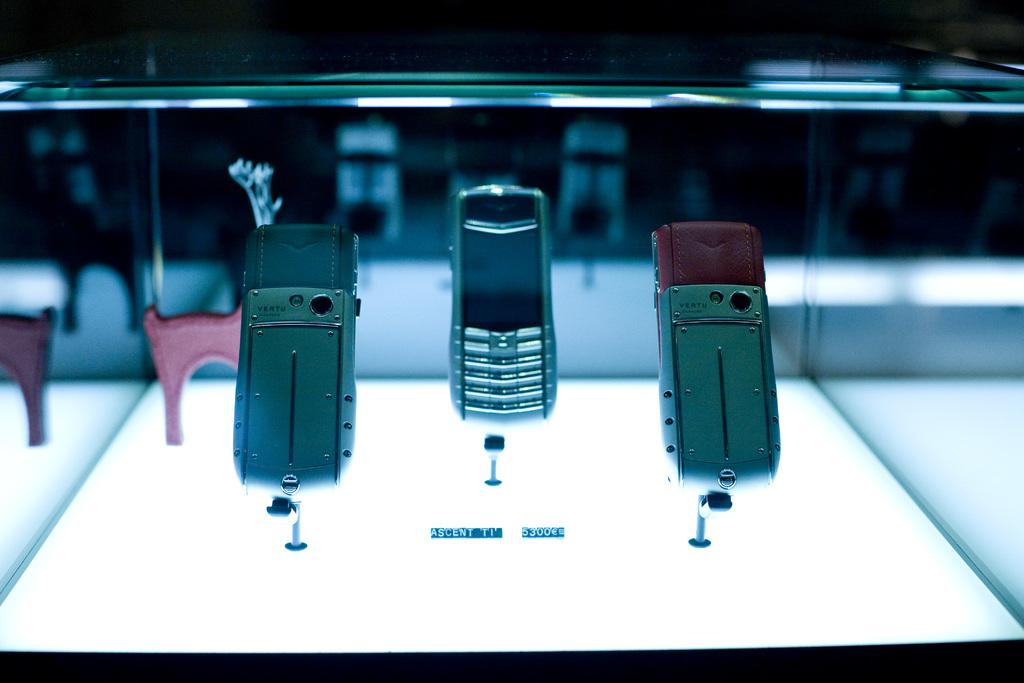<image>
Write a terse but informative summary of the picture. Several phones in a glass display with the caption Ascent TI 5300e 